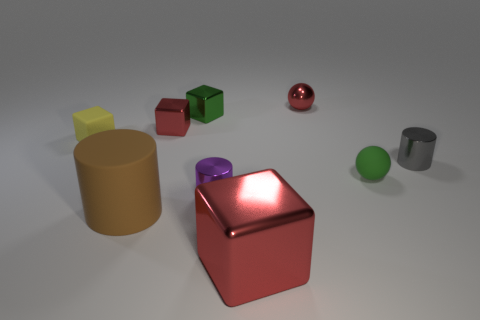Is the number of tiny metal cubes that are to the left of the tiny yellow matte cube the same as the number of big yellow metal spheres?
Provide a succinct answer. Yes. What shape is the big thing that is the same color as the metallic sphere?
Offer a very short reply. Cube. How many red metallic spheres have the same size as the yellow matte thing?
Offer a terse response. 1. How many shiny spheres are right of the shiny sphere?
Your response must be concise. 0. What is the material of the tiny sphere that is in front of the ball that is behind the matte cube?
Your response must be concise. Rubber. Are there any shiny spheres that have the same color as the big metallic cube?
Your answer should be very brief. Yes. What size is the gray cylinder that is made of the same material as the tiny red sphere?
Offer a very short reply. Small. Are there any other things of the same color as the large cube?
Keep it short and to the point. Yes. The small cylinder on the right side of the large red shiny thing is what color?
Provide a short and direct response. Gray. There is a tiny cylinder that is right of the small shiny sphere that is behind the green matte sphere; are there any small matte objects to the left of it?
Your response must be concise. Yes. 